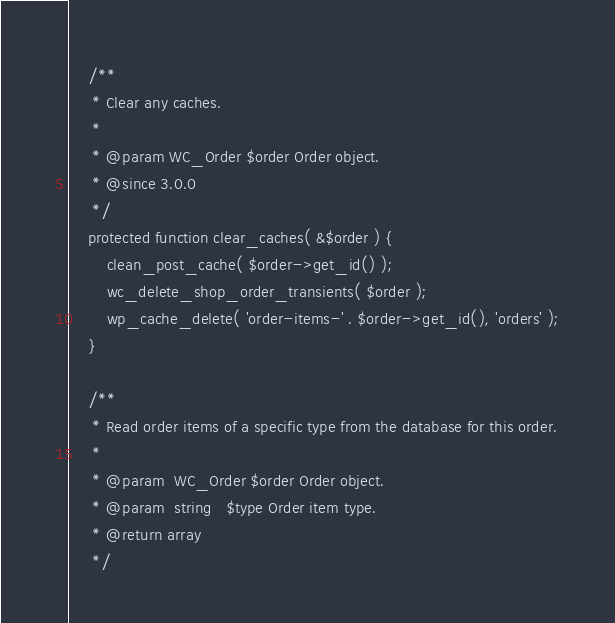Convert code to text. <code><loc_0><loc_0><loc_500><loc_500><_PHP_>
	/**
	 * Clear any caches.
	 *
	 * @param WC_Order $order Order object.
	 * @since 3.0.0
	 */
	protected function clear_caches( &$order ) {
		clean_post_cache( $order->get_id() );
		wc_delete_shop_order_transients( $order );
		wp_cache_delete( 'order-items-' . $order->get_id(), 'orders' );
	}

	/**
	 * Read order items of a specific type from the database for this order.
	 *
	 * @param  WC_Order $order Order object.
	 * @param  string   $type Order item type.
	 * @return array
	 */</code> 